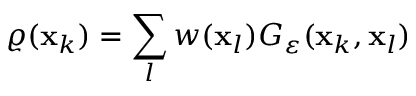<formula> <loc_0><loc_0><loc_500><loc_500>\varrho ( x _ { k } ) = \sum _ { l } w ( x _ { l } ) G _ { \varepsilon } ( x _ { k } , x _ { l } )</formula> 